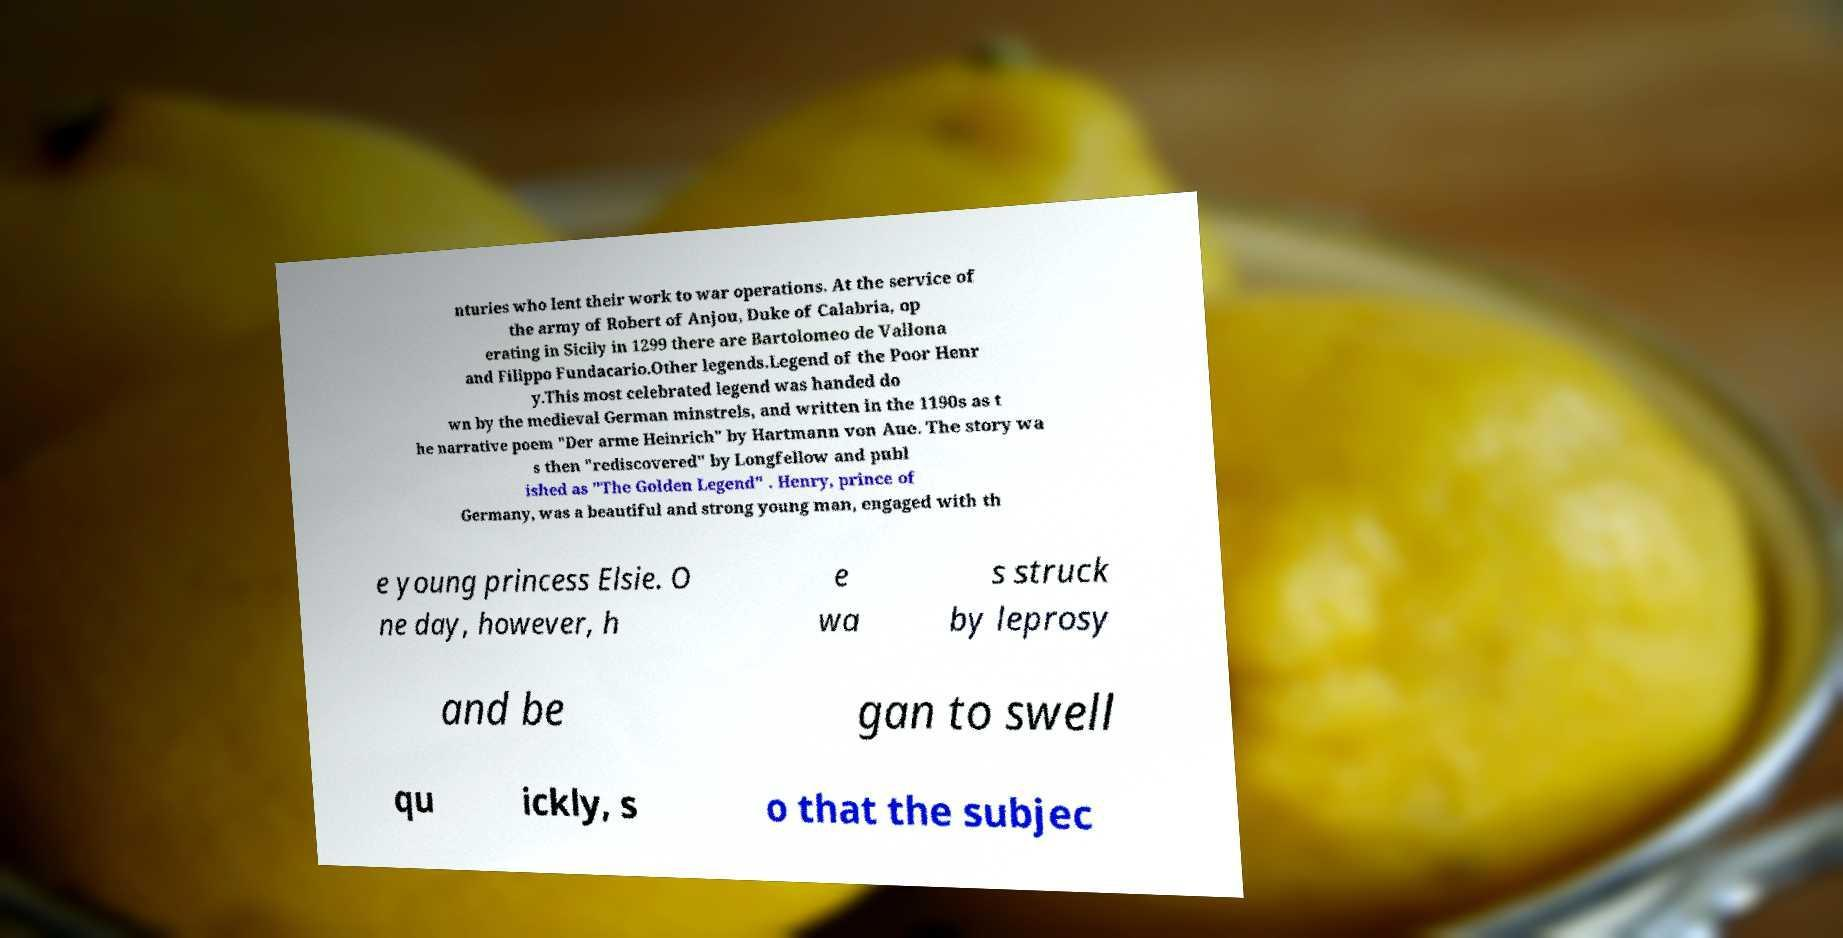What messages or text are displayed in this image? I need them in a readable, typed format. nturies who lent their work to war operations. At the service of the army of Robert of Anjou, Duke of Calabria, op erating in Sicily in 1299 there are Bartolomeo de Vallona and Filippo Fundacario.Other legends.Legend of the Poor Henr y.This most celebrated legend was handed do wn by the medieval German minstrels, and written in the 1190s as t he narrative poem "Der arme Heinrich" by Hartmann von Aue. The story wa s then "rediscovered" by Longfellow and publ ished as "The Golden Legend" . Henry, prince of Germany, was a beautiful and strong young man, engaged with th e young princess Elsie. O ne day, however, h e wa s struck by leprosy and be gan to swell qu ickly, s o that the subjec 